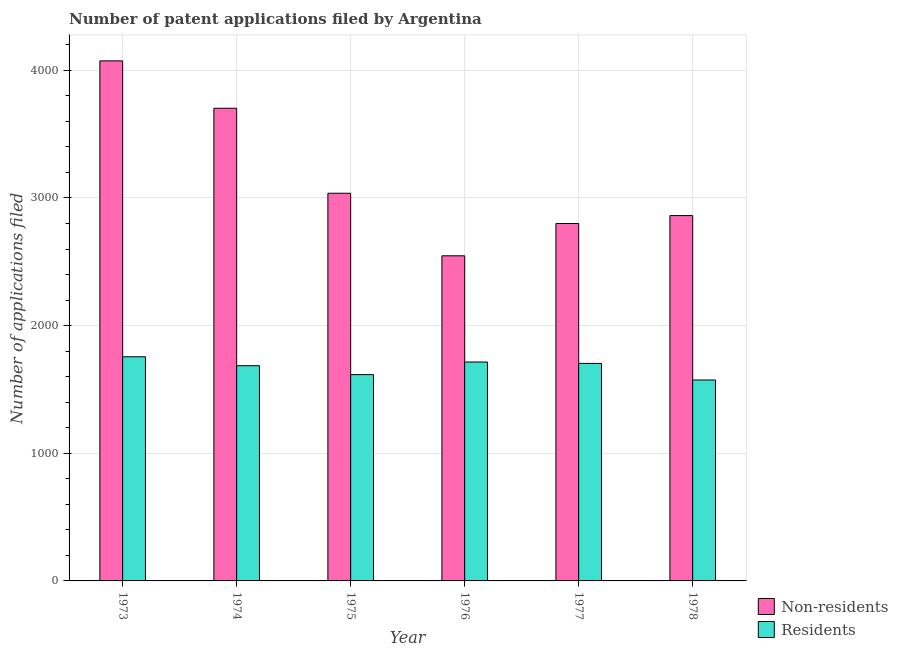Are the number of bars per tick equal to the number of legend labels?
Offer a terse response. Yes. How many bars are there on the 5th tick from the left?
Give a very brief answer. 2. What is the label of the 4th group of bars from the left?
Offer a very short reply. 1976. What is the number of patent applications by non residents in 1976?
Provide a succinct answer. 2547. Across all years, what is the maximum number of patent applications by non residents?
Provide a short and direct response. 4074. Across all years, what is the minimum number of patent applications by non residents?
Provide a short and direct response. 2547. In which year was the number of patent applications by non residents maximum?
Your response must be concise. 1973. In which year was the number of patent applications by residents minimum?
Provide a succinct answer. 1978. What is the total number of patent applications by non residents in the graph?
Offer a terse response. 1.90e+04. What is the difference between the number of patent applications by residents in 1974 and that in 1978?
Provide a short and direct response. 112. What is the difference between the number of patent applications by non residents in 1976 and the number of patent applications by residents in 1973?
Your answer should be compact. -1527. What is the average number of patent applications by residents per year?
Provide a short and direct response. 1675.17. In the year 1974, what is the difference between the number of patent applications by non residents and number of patent applications by residents?
Your answer should be very brief. 0. In how many years, is the number of patent applications by residents greater than 4000?
Ensure brevity in your answer.  0. What is the ratio of the number of patent applications by residents in 1975 to that in 1976?
Offer a terse response. 0.94. Is the number of patent applications by non residents in 1974 less than that in 1976?
Keep it short and to the point. No. Is the difference between the number of patent applications by residents in 1974 and 1976 greater than the difference between the number of patent applications by non residents in 1974 and 1976?
Provide a short and direct response. No. What is the difference between the highest and the lowest number of patent applications by residents?
Your response must be concise. 182. What does the 2nd bar from the left in 1977 represents?
Your answer should be very brief. Residents. What does the 1st bar from the right in 1976 represents?
Make the answer very short. Residents. How many bars are there?
Offer a terse response. 12. Does the graph contain any zero values?
Give a very brief answer. No. What is the title of the graph?
Your answer should be compact. Number of patent applications filed by Argentina. What is the label or title of the Y-axis?
Offer a very short reply. Number of applications filed. What is the Number of applications filed in Non-residents in 1973?
Ensure brevity in your answer.  4074. What is the Number of applications filed of Residents in 1973?
Provide a succinct answer. 1756. What is the Number of applications filed of Non-residents in 1974?
Keep it short and to the point. 3703. What is the Number of applications filed of Residents in 1974?
Keep it short and to the point. 1686. What is the Number of applications filed in Non-residents in 1975?
Provide a succinct answer. 3037. What is the Number of applications filed of Residents in 1975?
Your answer should be very brief. 1616. What is the Number of applications filed of Non-residents in 1976?
Keep it short and to the point. 2547. What is the Number of applications filed of Residents in 1976?
Your answer should be compact. 1715. What is the Number of applications filed in Non-residents in 1977?
Make the answer very short. 2800. What is the Number of applications filed of Residents in 1977?
Offer a very short reply. 1704. What is the Number of applications filed in Non-residents in 1978?
Provide a succinct answer. 2862. What is the Number of applications filed of Residents in 1978?
Make the answer very short. 1574. Across all years, what is the maximum Number of applications filed in Non-residents?
Make the answer very short. 4074. Across all years, what is the maximum Number of applications filed of Residents?
Give a very brief answer. 1756. Across all years, what is the minimum Number of applications filed in Non-residents?
Ensure brevity in your answer.  2547. Across all years, what is the minimum Number of applications filed of Residents?
Offer a very short reply. 1574. What is the total Number of applications filed in Non-residents in the graph?
Offer a very short reply. 1.90e+04. What is the total Number of applications filed in Residents in the graph?
Keep it short and to the point. 1.01e+04. What is the difference between the Number of applications filed of Non-residents in 1973 and that in 1974?
Make the answer very short. 371. What is the difference between the Number of applications filed of Non-residents in 1973 and that in 1975?
Offer a terse response. 1037. What is the difference between the Number of applications filed in Residents in 1973 and that in 1975?
Ensure brevity in your answer.  140. What is the difference between the Number of applications filed of Non-residents in 1973 and that in 1976?
Your answer should be compact. 1527. What is the difference between the Number of applications filed in Non-residents in 1973 and that in 1977?
Keep it short and to the point. 1274. What is the difference between the Number of applications filed of Non-residents in 1973 and that in 1978?
Offer a terse response. 1212. What is the difference between the Number of applications filed of Residents in 1973 and that in 1978?
Your answer should be compact. 182. What is the difference between the Number of applications filed in Non-residents in 1974 and that in 1975?
Give a very brief answer. 666. What is the difference between the Number of applications filed of Non-residents in 1974 and that in 1976?
Your response must be concise. 1156. What is the difference between the Number of applications filed of Non-residents in 1974 and that in 1977?
Your response must be concise. 903. What is the difference between the Number of applications filed of Residents in 1974 and that in 1977?
Provide a succinct answer. -18. What is the difference between the Number of applications filed in Non-residents in 1974 and that in 1978?
Offer a very short reply. 841. What is the difference between the Number of applications filed of Residents in 1974 and that in 1978?
Offer a terse response. 112. What is the difference between the Number of applications filed of Non-residents in 1975 and that in 1976?
Offer a very short reply. 490. What is the difference between the Number of applications filed in Residents in 1975 and that in 1976?
Provide a succinct answer. -99. What is the difference between the Number of applications filed in Non-residents in 1975 and that in 1977?
Provide a succinct answer. 237. What is the difference between the Number of applications filed of Residents in 1975 and that in 1977?
Offer a terse response. -88. What is the difference between the Number of applications filed of Non-residents in 1975 and that in 1978?
Give a very brief answer. 175. What is the difference between the Number of applications filed of Residents in 1975 and that in 1978?
Your answer should be compact. 42. What is the difference between the Number of applications filed in Non-residents in 1976 and that in 1977?
Your answer should be compact. -253. What is the difference between the Number of applications filed of Non-residents in 1976 and that in 1978?
Offer a very short reply. -315. What is the difference between the Number of applications filed in Residents in 1976 and that in 1978?
Offer a terse response. 141. What is the difference between the Number of applications filed of Non-residents in 1977 and that in 1978?
Keep it short and to the point. -62. What is the difference between the Number of applications filed in Residents in 1977 and that in 1978?
Provide a succinct answer. 130. What is the difference between the Number of applications filed in Non-residents in 1973 and the Number of applications filed in Residents in 1974?
Provide a succinct answer. 2388. What is the difference between the Number of applications filed in Non-residents in 1973 and the Number of applications filed in Residents in 1975?
Provide a succinct answer. 2458. What is the difference between the Number of applications filed in Non-residents in 1973 and the Number of applications filed in Residents in 1976?
Your response must be concise. 2359. What is the difference between the Number of applications filed of Non-residents in 1973 and the Number of applications filed of Residents in 1977?
Provide a succinct answer. 2370. What is the difference between the Number of applications filed in Non-residents in 1973 and the Number of applications filed in Residents in 1978?
Provide a short and direct response. 2500. What is the difference between the Number of applications filed of Non-residents in 1974 and the Number of applications filed of Residents in 1975?
Provide a succinct answer. 2087. What is the difference between the Number of applications filed of Non-residents in 1974 and the Number of applications filed of Residents in 1976?
Provide a succinct answer. 1988. What is the difference between the Number of applications filed of Non-residents in 1974 and the Number of applications filed of Residents in 1977?
Provide a succinct answer. 1999. What is the difference between the Number of applications filed of Non-residents in 1974 and the Number of applications filed of Residents in 1978?
Keep it short and to the point. 2129. What is the difference between the Number of applications filed in Non-residents in 1975 and the Number of applications filed in Residents in 1976?
Your response must be concise. 1322. What is the difference between the Number of applications filed of Non-residents in 1975 and the Number of applications filed of Residents in 1977?
Make the answer very short. 1333. What is the difference between the Number of applications filed of Non-residents in 1975 and the Number of applications filed of Residents in 1978?
Keep it short and to the point. 1463. What is the difference between the Number of applications filed of Non-residents in 1976 and the Number of applications filed of Residents in 1977?
Keep it short and to the point. 843. What is the difference between the Number of applications filed in Non-residents in 1976 and the Number of applications filed in Residents in 1978?
Your answer should be very brief. 973. What is the difference between the Number of applications filed of Non-residents in 1977 and the Number of applications filed of Residents in 1978?
Ensure brevity in your answer.  1226. What is the average Number of applications filed of Non-residents per year?
Provide a short and direct response. 3170.5. What is the average Number of applications filed of Residents per year?
Your answer should be compact. 1675.17. In the year 1973, what is the difference between the Number of applications filed of Non-residents and Number of applications filed of Residents?
Your response must be concise. 2318. In the year 1974, what is the difference between the Number of applications filed in Non-residents and Number of applications filed in Residents?
Give a very brief answer. 2017. In the year 1975, what is the difference between the Number of applications filed of Non-residents and Number of applications filed of Residents?
Provide a short and direct response. 1421. In the year 1976, what is the difference between the Number of applications filed of Non-residents and Number of applications filed of Residents?
Offer a terse response. 832. In the year 1977, what is the difference between the Number of applications filed in Non-residents and Number of applications filed in Residents?
Provide a succinct answer. 1096. In the year 1978, what is the difference between the Number of applications filed in Non-residents and Number of applications filed in Residents?
Provide a short and direct response. 1288. What is the ratio of the Number of applications filed of Non-residents in 1973 to that in 1974?
Keep it short and to the point. 1.1. What is the ratio of the Number of applications filed in Residents in 1973 to that in 1974?
Ensure brevity in your answer.  1.04. What is the ratio of the Number of applications filed of Non-residents in 1973 to that in 1975?
Your answer should be compact. 1.34. What is the ratio of the Number of applications filed in Residents in 1973 to that in 1975?
Keep it short and to the point. 1.09. What is the ratio of the Number of applications filed of Non-residents in 1973 to that in 1976?
Ensure brevity in your answer.  1.6. What is the ratio of the Number of applications filed of Residents in 1973 to that in 1976?
Offer a very short reply. 1.02. What is the ratio of the Number of applications filed in Non-residents in 1973 to that in 1977?
Your answer should be very brief. 1.46. What is the ratio of the Number of applications filed in Residents in 1973 to that in 1977?
Your response must be concise. 1.03. What is the ratio of the Number of applications filed in Non-residents in 1973 to that in 1978?
Keep it short and to the point. 1.42. What is the ratio of the Number of applications filed in Residents in 1973 to that in 1978?
Make the answer very short. 1.12. What is the ratio of the Number of applications filed in Non-residents in 1974 to that in 1975?
Your response must be concise. 1.22. What is the ratio of the Number of applications filed of Residents in 1974 to that in 1975?
Your response must be concise. 1.04. What is the ratio of the Number of applications filed of Non-residents in 1974 to that in 1976?
Provide a succinct answer. 1.45. What is the ratio of the Number of applications filed of Residents in 1974 to that in 1976?
Offer a terse response. 0.98. What is the ratio of the Number of applications filed in Non-residents in 1974 to that in 1977?
Ensure brevity in your answer.  1.32. What is the ratio of the Number of applications filed of Residents in 1974 to that in 1977?
Provide a succinct answer. 0.99. What is the ratio of the Number of applications filed in Non-residents in 1974 to that in 1978?
Keep it short and to the point. 1.29. What is the ratio of the Number of applications filed in Residents in 1974 to that in 1978?
Your response must be concise. 1.07. What is the ratio of the Number of applications filed in Non-residents in 1975 to that in 1976?
Provide a short and direct response. 1.19. What is the ratio of the Number of applications filed in Residents in 1975 to that in 1976?
Offer a terse response. 0.94. What is the ratio of the Number of applications filed of Non-residents in 1975 to that in 1977?
Your answer should be compact. 1.08. What is the ratio of the Number of applications filed in Residents in 1975 to that in 1977?
Your answer should be very brief. 0.95. What is the ratio of the Number of applications filed in Non-residents in 1975 to that in 1978?
Offer a very short reply. 1.06. What is the ratio of the Number of applications filed of Residents in 1975 to that in 1978?
Provide a succinct answer. 1.03. What is the ratio of the Number of applications filed of Non-residents in 1976 to that in 1977?
Give a very brief answer. 0.91. What is the ratio of the Number of applications filed of Non-residents in 1976 to that in 1978?
Your response must be concise. 0.89. What is the ratio of the Number of applications filed of Residents in 1976 to that in 1978?
Give a very brief answer. 1.09. What is the ratio of the Number of applications filed of Non-residents in 1977 to that in 1978?
Provide a succinct answer. 0.98. What is the ratio of the Number of applications filed in Residents in 1977 to that in 1978?
Offer a very short reply. 1.08. What is the difference between the highest and the second highest Number of applications filed in Non-residents?
Provide a short and direct response. 371. What is the difference between the highest and the lowest Number of applications filed of Non-residents?
Your response must be concise. 1527. What is the difference between the highest and the lowest Number of applications filed in Residents?
Your answer should be very brief. 182. 